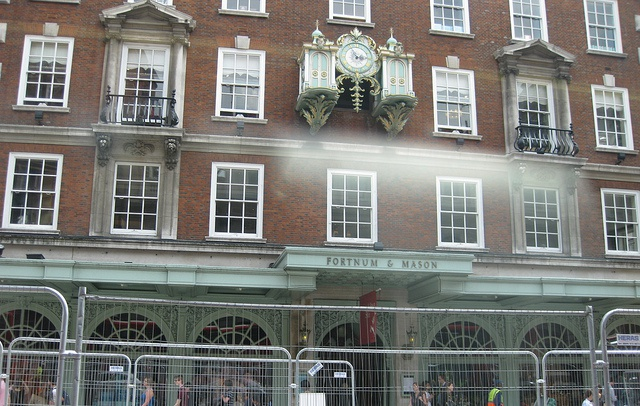Describe the objects in this image and their specific colors. I can see people in gray, black, darkgray, and blue tones, clock in gray, lightgray, lightblue, darkgray, and beige tones, people in gray and black tones, people in gray, darkgray, and teal tones, and people in gray and darkgray tones in this image. 